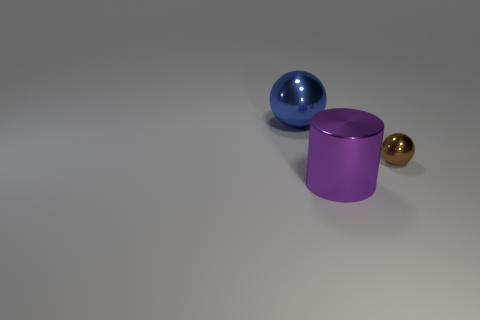There is a sphere right of the big purple metallic object; is its size the same as the thing that is left of the purple object?
Make the answer very short. No. What is the shape of the thing that is left of the tiny brown metal object and behind the large cylinder?
Give a very brief answer. Sphere. Is there a blue ball that has the same material as the big cylinder?
Offer a terse response. Yes. Are the purple cylinder in front of the large blue shiny object and the thing that is left of the big cylinder made of the same material?
Give a very brief answer. Yes. Is the number of big purple metallic objects greater than the number of big cyan matte cubes?
Your answer should be very brief. Yes. What is the color of the metal sphere in front of the object behind the shiny sphere in front of the large blue thing?
Make the answer very short. Brown. There is a big blue thing behind the large purple metallic thing; what number of blue things are in front of it?
Your answer should be very brief. 0. Are any tiny green metal cylinders visible?
Provide a short and direct response. No. What number of other objects are the same color as the big metal ball?
Keep it short and to the point. 0. Are there fewer small objects than green cylinders?
Provide a succinct answer. No. 